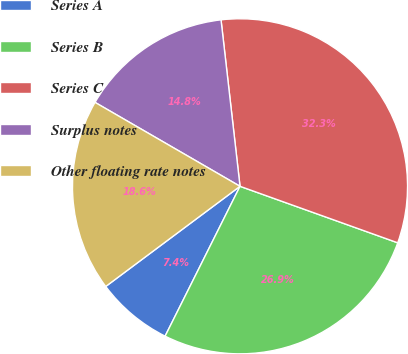Convert chart to OTSL. <chart><loc_0><loc_0><loc_500><loc_500><pie_chart><fcel>Series A<fcel>Series B<fcel>Series C<fcel>Surplus notes<fcel>Other floating rate notes<nl><fcel>7.42%<fcel>26.9%<fcel>32.28%<fcel>14.84%<fcel>18.55%<nl></chart> 